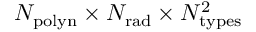<formula> <loc_0><loc_0><loc_500><loc_500>N _ { p o l y n } \times N _ { r a d } \times N _ { t y p e s } ^ { 2 }</formula> 